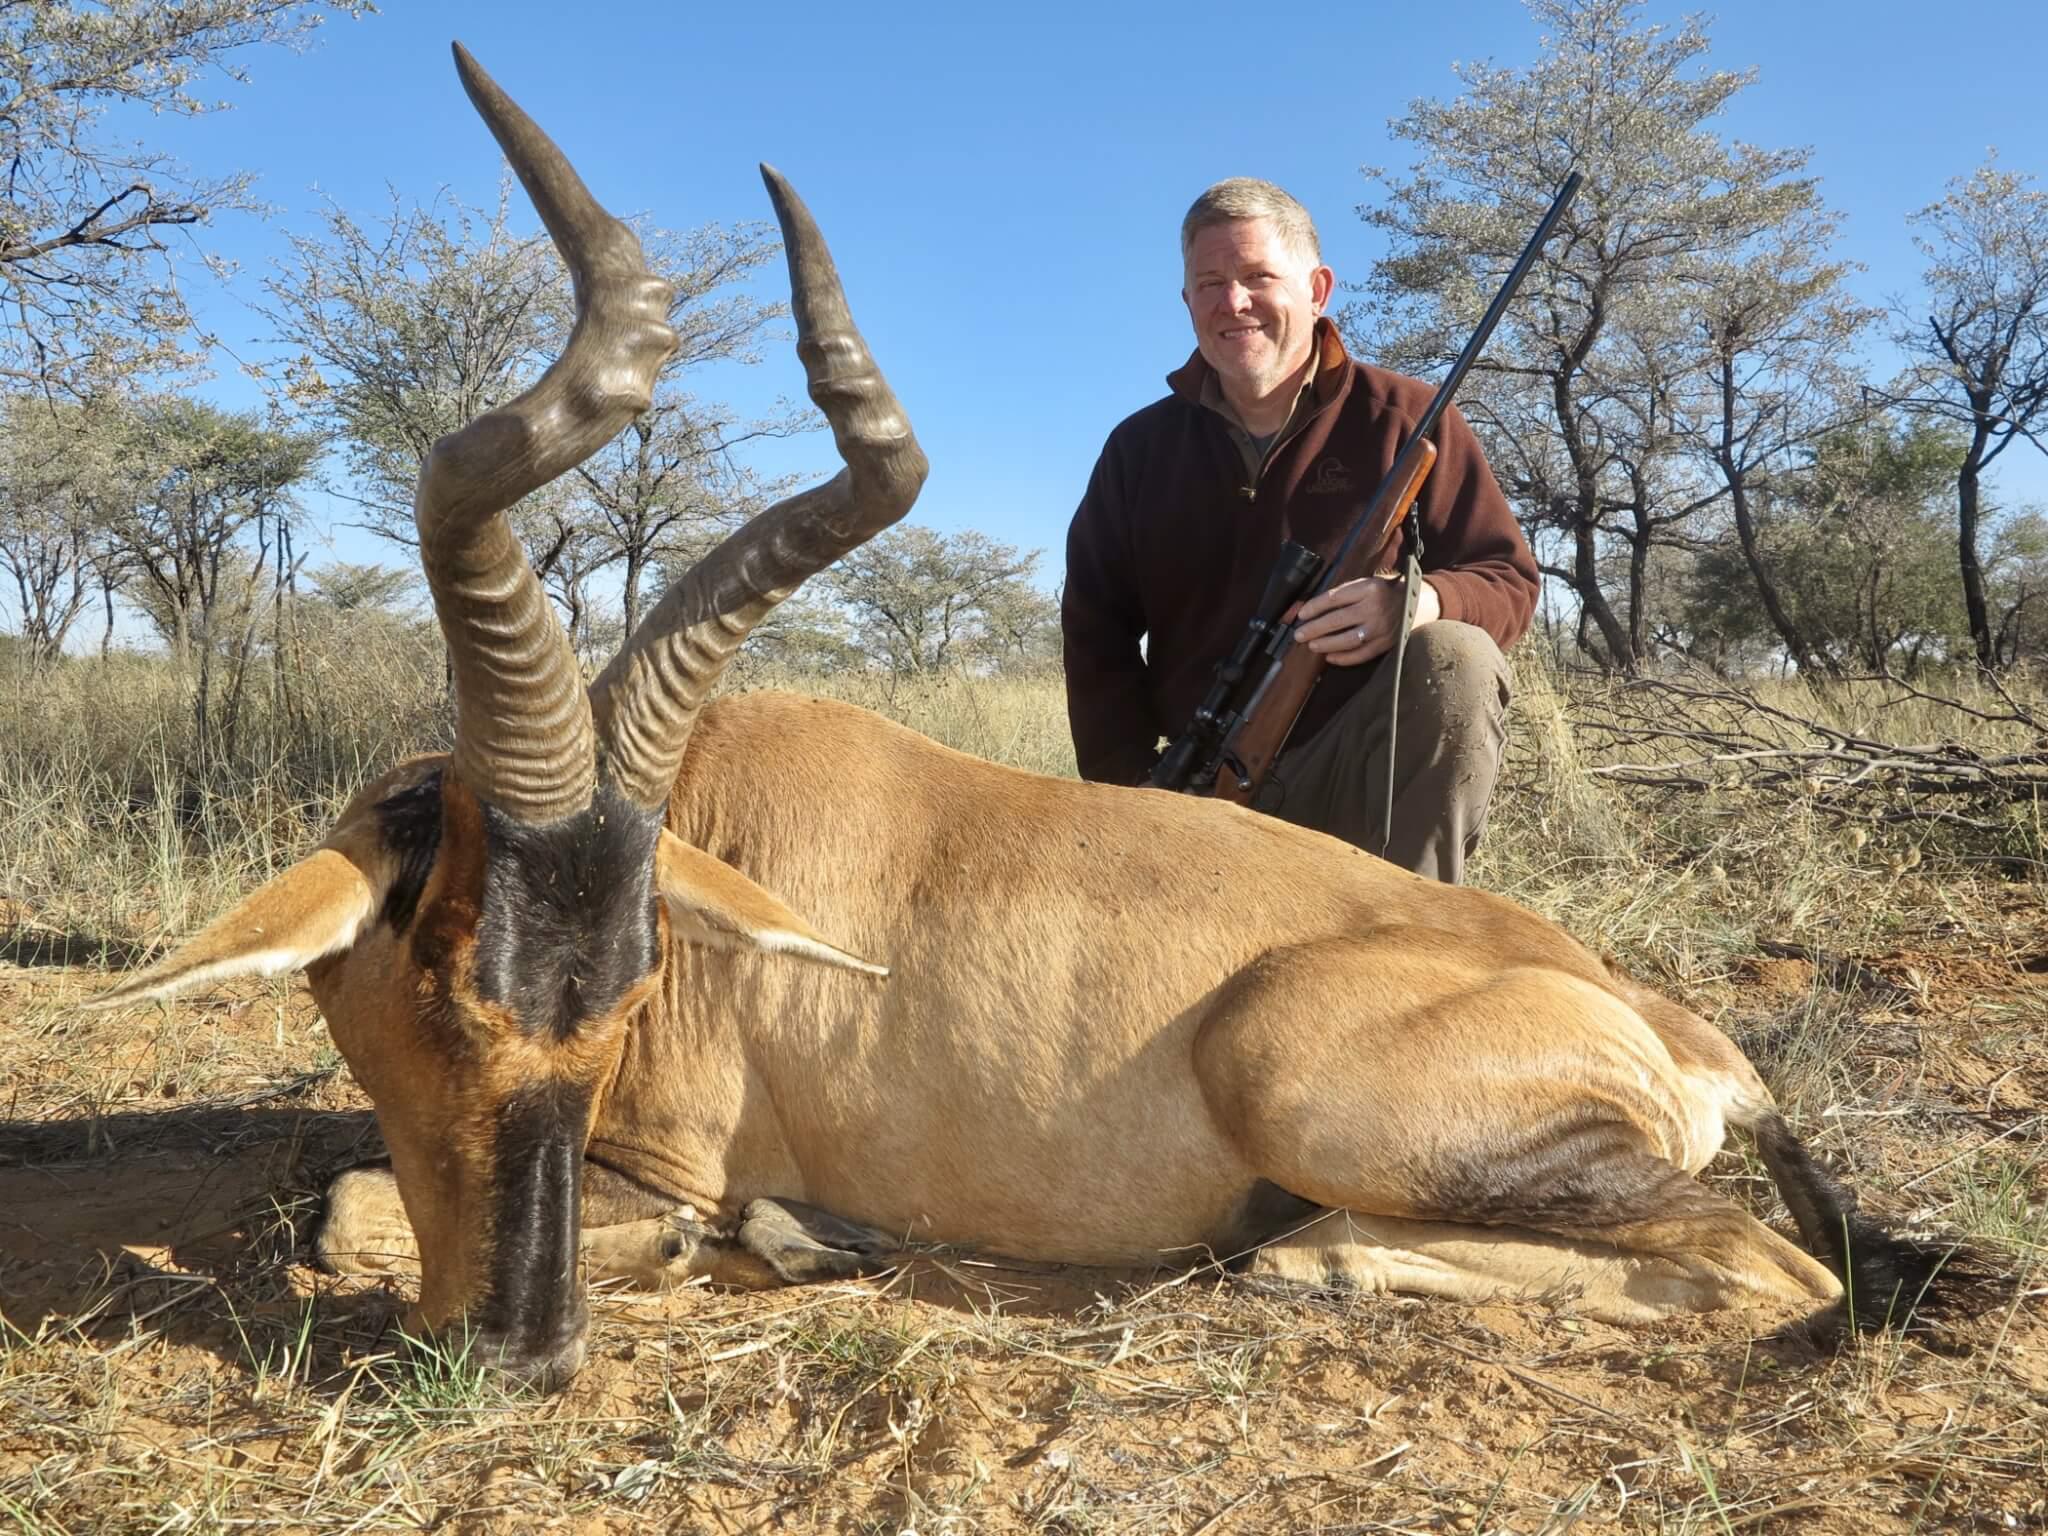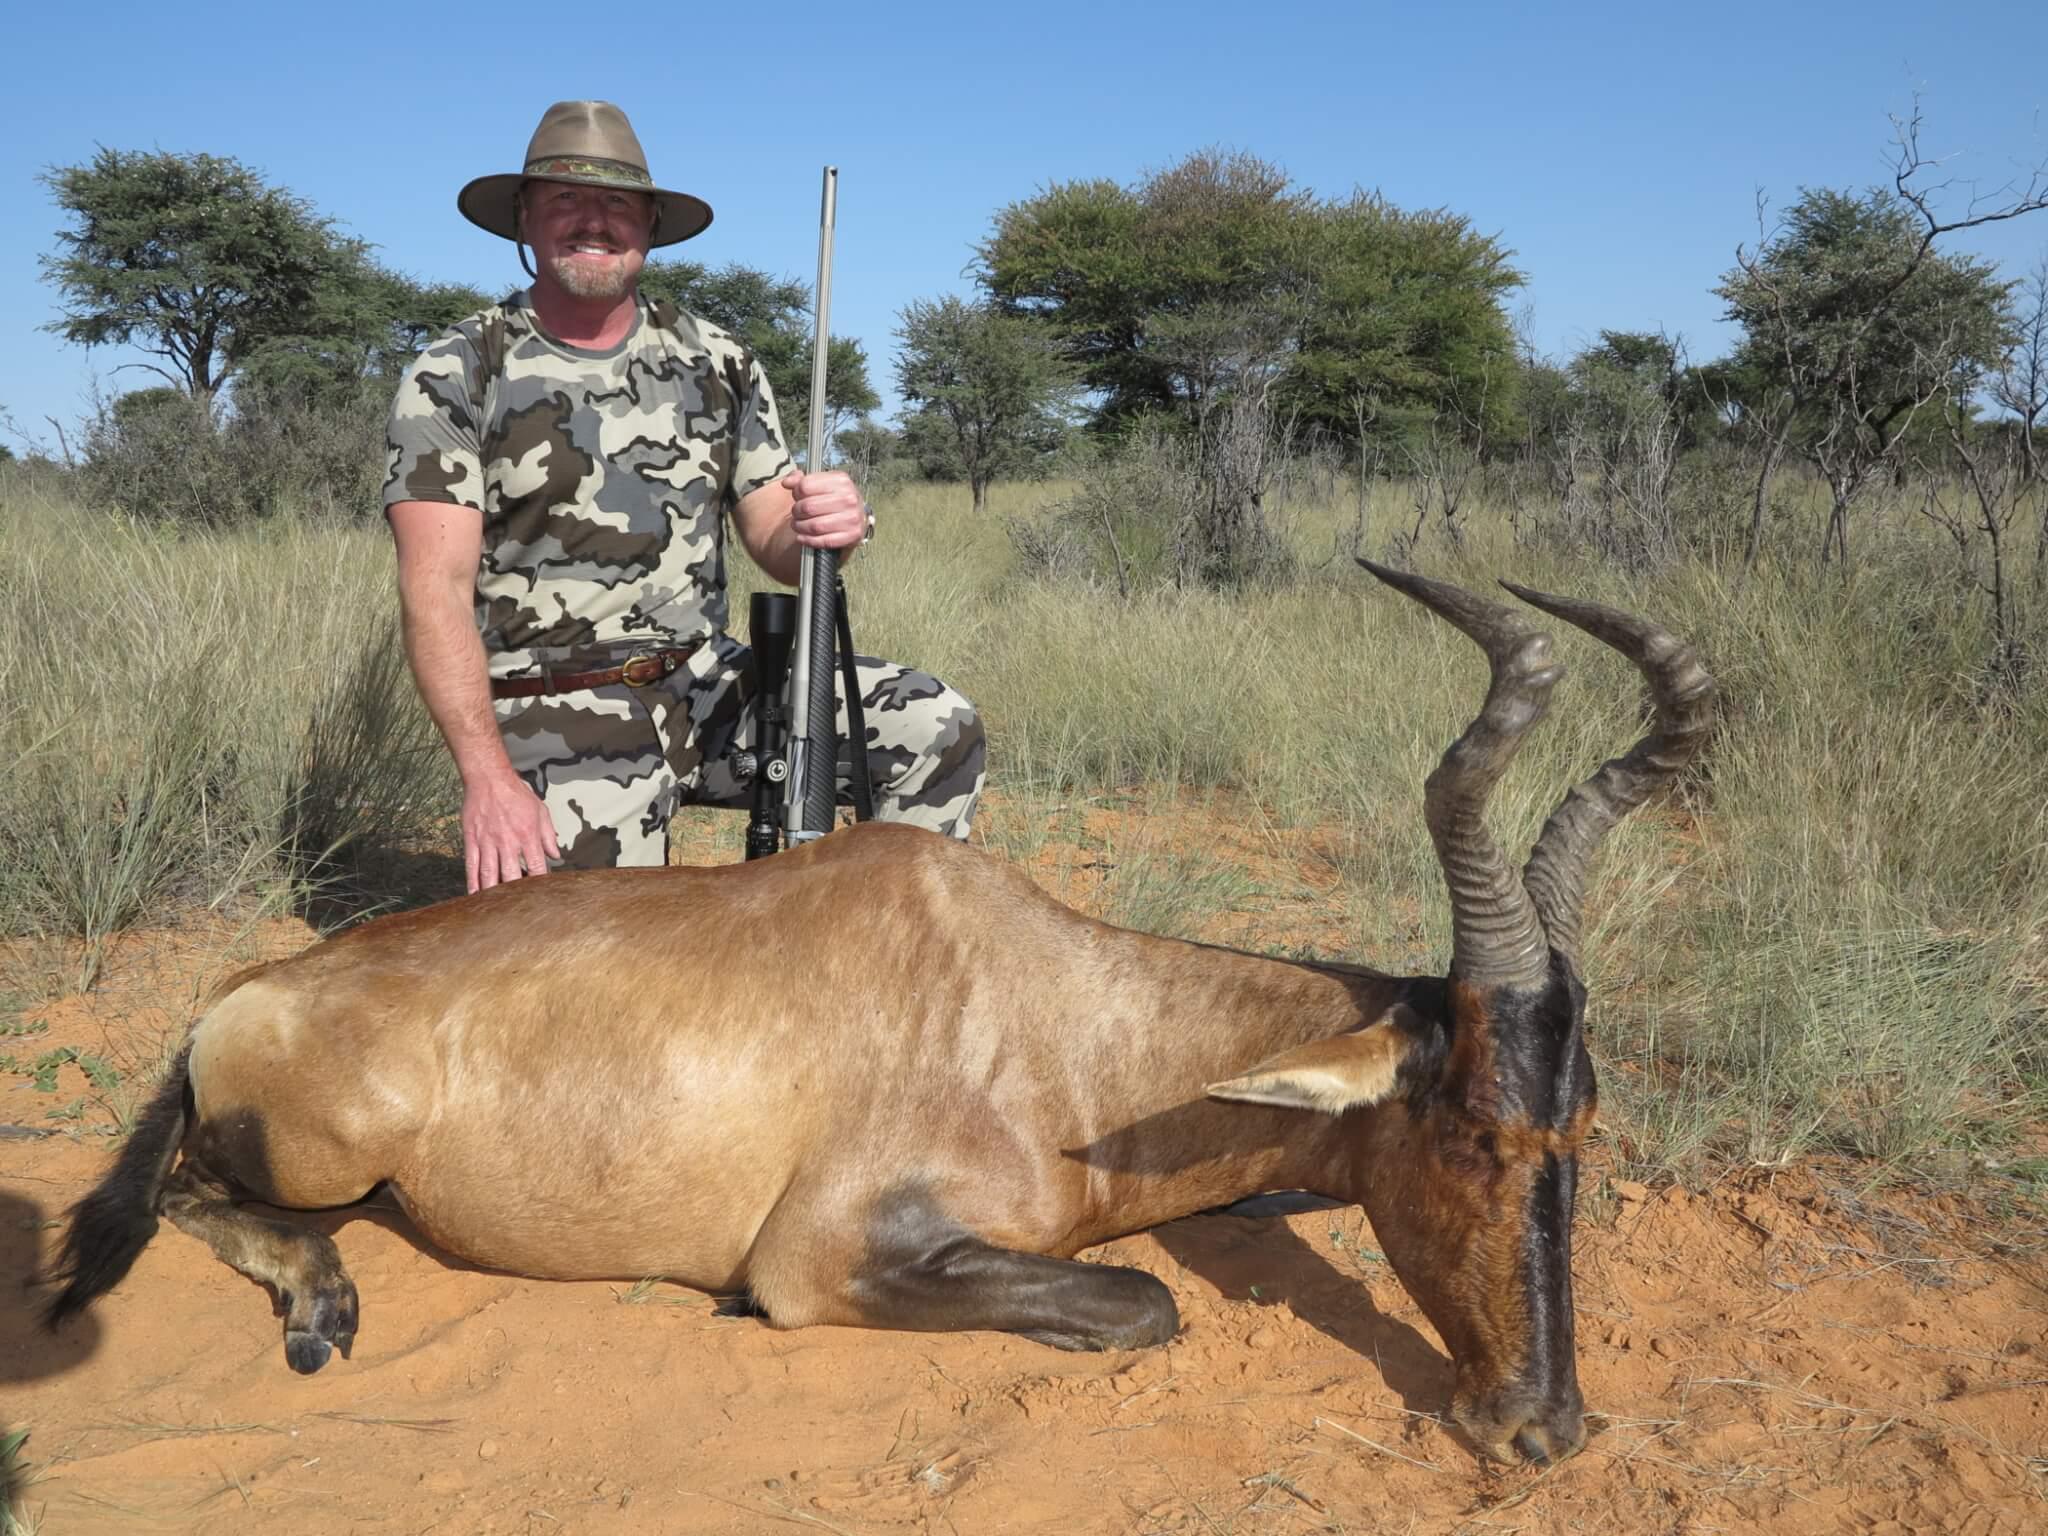The first image is the image on the left, the second image is the image on the right. Considering the images on both sides, is "In one image, a hunter in a hat holding a rifle vertically is behind a downed horned animal with its head to the right." valid? Answer yes or no. Yes. 